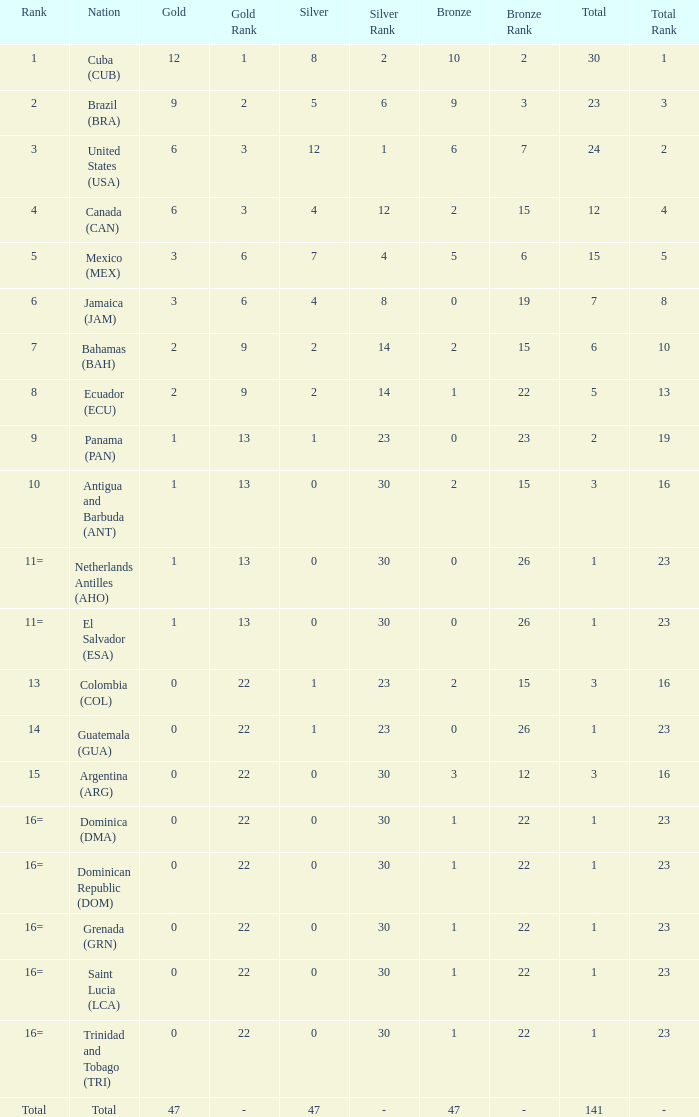What is the average silver with more than 0 gold, a Rank of 1, and a Total smaller than 30? None. 